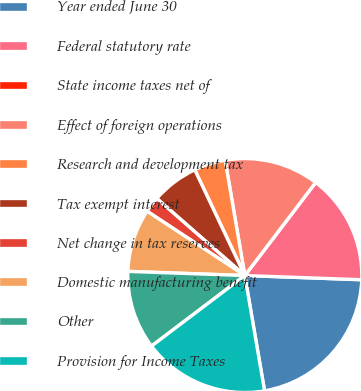<chart> <loc_0><loc_0><loc_500><loc_500><pie_chart><fcel>Year ended June 30<fcel>Federal statutory rate<fcel>State income taxes net of<fcel>Effect of foreign operations<fcel>Research and development tax<fcel>Tax exempt interest<fcel>Net change in tax reserves<fcel>Domestic manufacturing benefit<fcel>Other<fcel>Provision for Income Taxes<nl><fcel>21.73%<fcel>15.22%<fcel>0.0%<fcel>13.04%<fcel>4.35%<fcel>6.52%<fcel>2.18%<fcel>8.7%<fcel>10.87%<fcel>17.39%<nl></chart> 